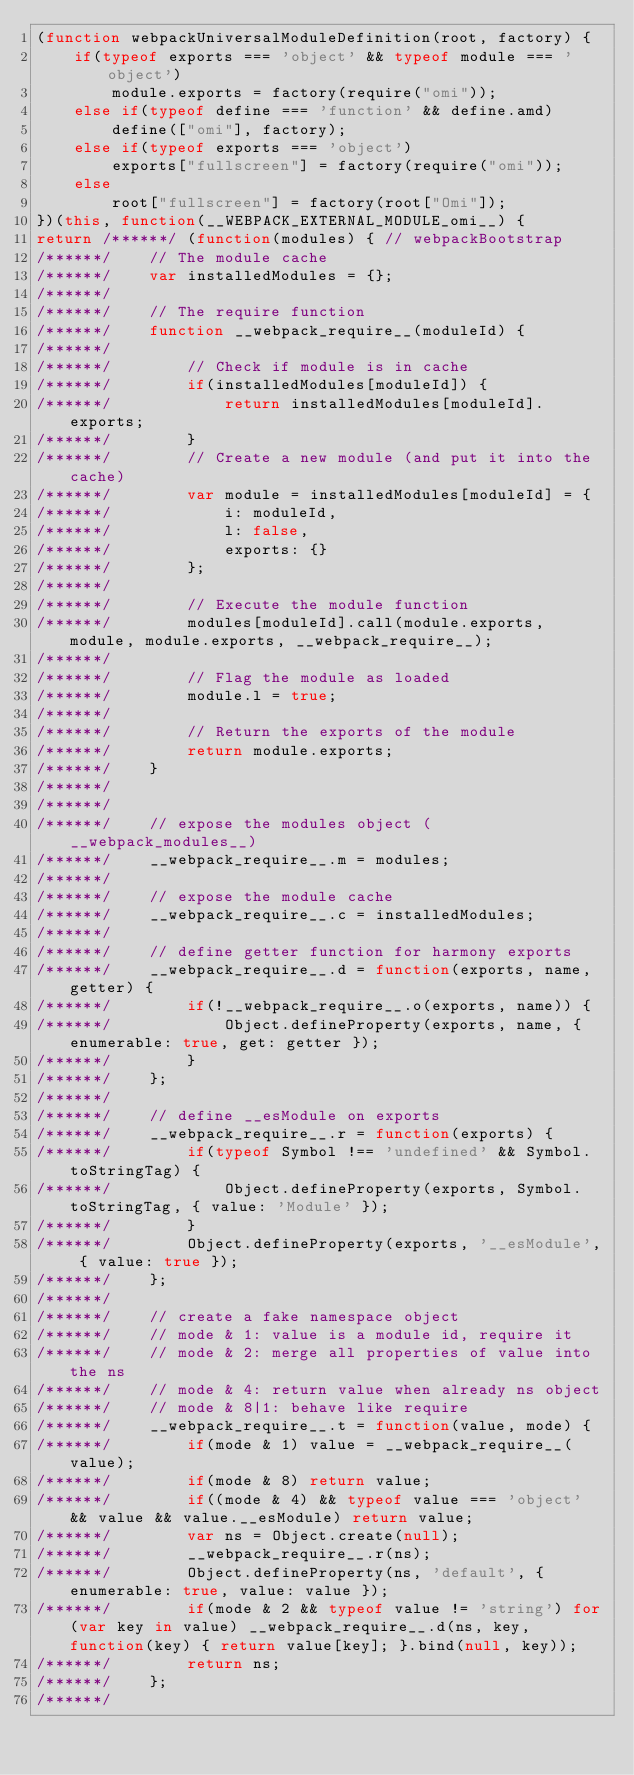Convert code to text. <code><loc_0><loc_0><loc_500><loc_500><_JavaScript_>(function webpackUniversalModuleDefinition(root, factory) {
	if(typeof exports === 'object' && typeof module === 'object')
		module.exports = factory(require("omi"));
	else if(typeof define === 'function' && define.amd)
		define(["omi"], factory);
	else if(typeof exports === 'object')
		exports["fullscreen"] = factory(require("omi"));
	else
		root["fullscreen"] = factory(root["Omi"]);
})(this, function(__WEBPACK_EXTERNAL_MODULE_omi__) {
return /******/ (function(modules) { // webpackBootstrap
/******/ 	// The module cache
/******/ 	var installedModules = {};
/******/
/******/ 	// The require function
/******/ 	function __webpack_require__(moduleId) {
/******/
/******/ 		// Check if module is in cache
/******/ 		if(installedModules[moduleId]) {
/******/ 			return installedModules[moduleId].exports;
/******/ 		}
/******/ 		// Create a new module (and put it into the cache)
/******/ 		var module = installedModules[moduleId] = {
/******/ 			i: moduleId,
/******/ 			l: false,
/******/ 			exports: {}
/******/ 		};
/******/
/******/ 		// Execute the module function
/******/ 		modules[moduleId].call(module.exports, module, module.exports, __webpack_require__);
/******/
/******/ 		// Flag the module as loaded
/******/ 		module.l = true;
/******/
/******/ 		// Return the exports of the module
/******/ 		return module.exports;
/******/ 	}
/******/
/******/
/******/ 	// expose the modules object (__webpack_modules__)
/******/ 	__webpack_require__.m = modules;
/******/
/******/ 	// expose the module cache
/******/ 	__webpack_require__.c = installedModules;
/******/
/******/ 	// define getter function for harmony exports
/******/ 	__webpack_require__.d = function(exports, name, getter) {
/******/ 		if(!__webpack_require__.o(exports, name)) {
/******/ 			Object.defineProperty(exports, name, { enumerable: true, get: getter });
/******/ 		}
/******/ 	};
/******/
/******/ 	// define __esModule on exports
/******/ 	__webpack_require__.r = function(exports) {
/******/ 		if(typeof Symbol !== 'undefined' && Symbol.toStringTag) {
/******/ 			Object.defineProperty(exports, Symbol.toStringTag, { value: 'Module' });
/******/ 		}
/******/ 		Object.defineProperty(exports, '__esModule', { value: true });
/******/ 	};
/******/
/******/ 	// create a fake namespace object
/******/ 	// mode & 1: value is a module id, require it
/******/ 	// mode & 2: merge all properties of value into the ns
/******/ 	// mode & 4: return value when already ns object
/******/ 	// mode & 8|1: behave like require
/******/ 	__webpack_require__.t = function(value, mode) {
/******/ 		if(mode & 1) value = __webpack_require__(value);
/******/ 		if(mode & 8) return value;
/******/ 		if((mode & 4) && typeof value === 'object' && value && value.__esModule) return value;
/******/ 		var ns = Object.create(null);
/******/ 		__webpack_require__.r(ns);
/******/ 		Object.defineProperty(ns, 'default', { enumerable: true, value: value });
/******/ 		if(mode & 2 && typeof value != 'string') for(var key in value) __webpack_require__.d(ns, key, function(key) { return value[key]; }.bind(null, key));
/******/ 		return ns;
/******/ 	};
/******/</code> 